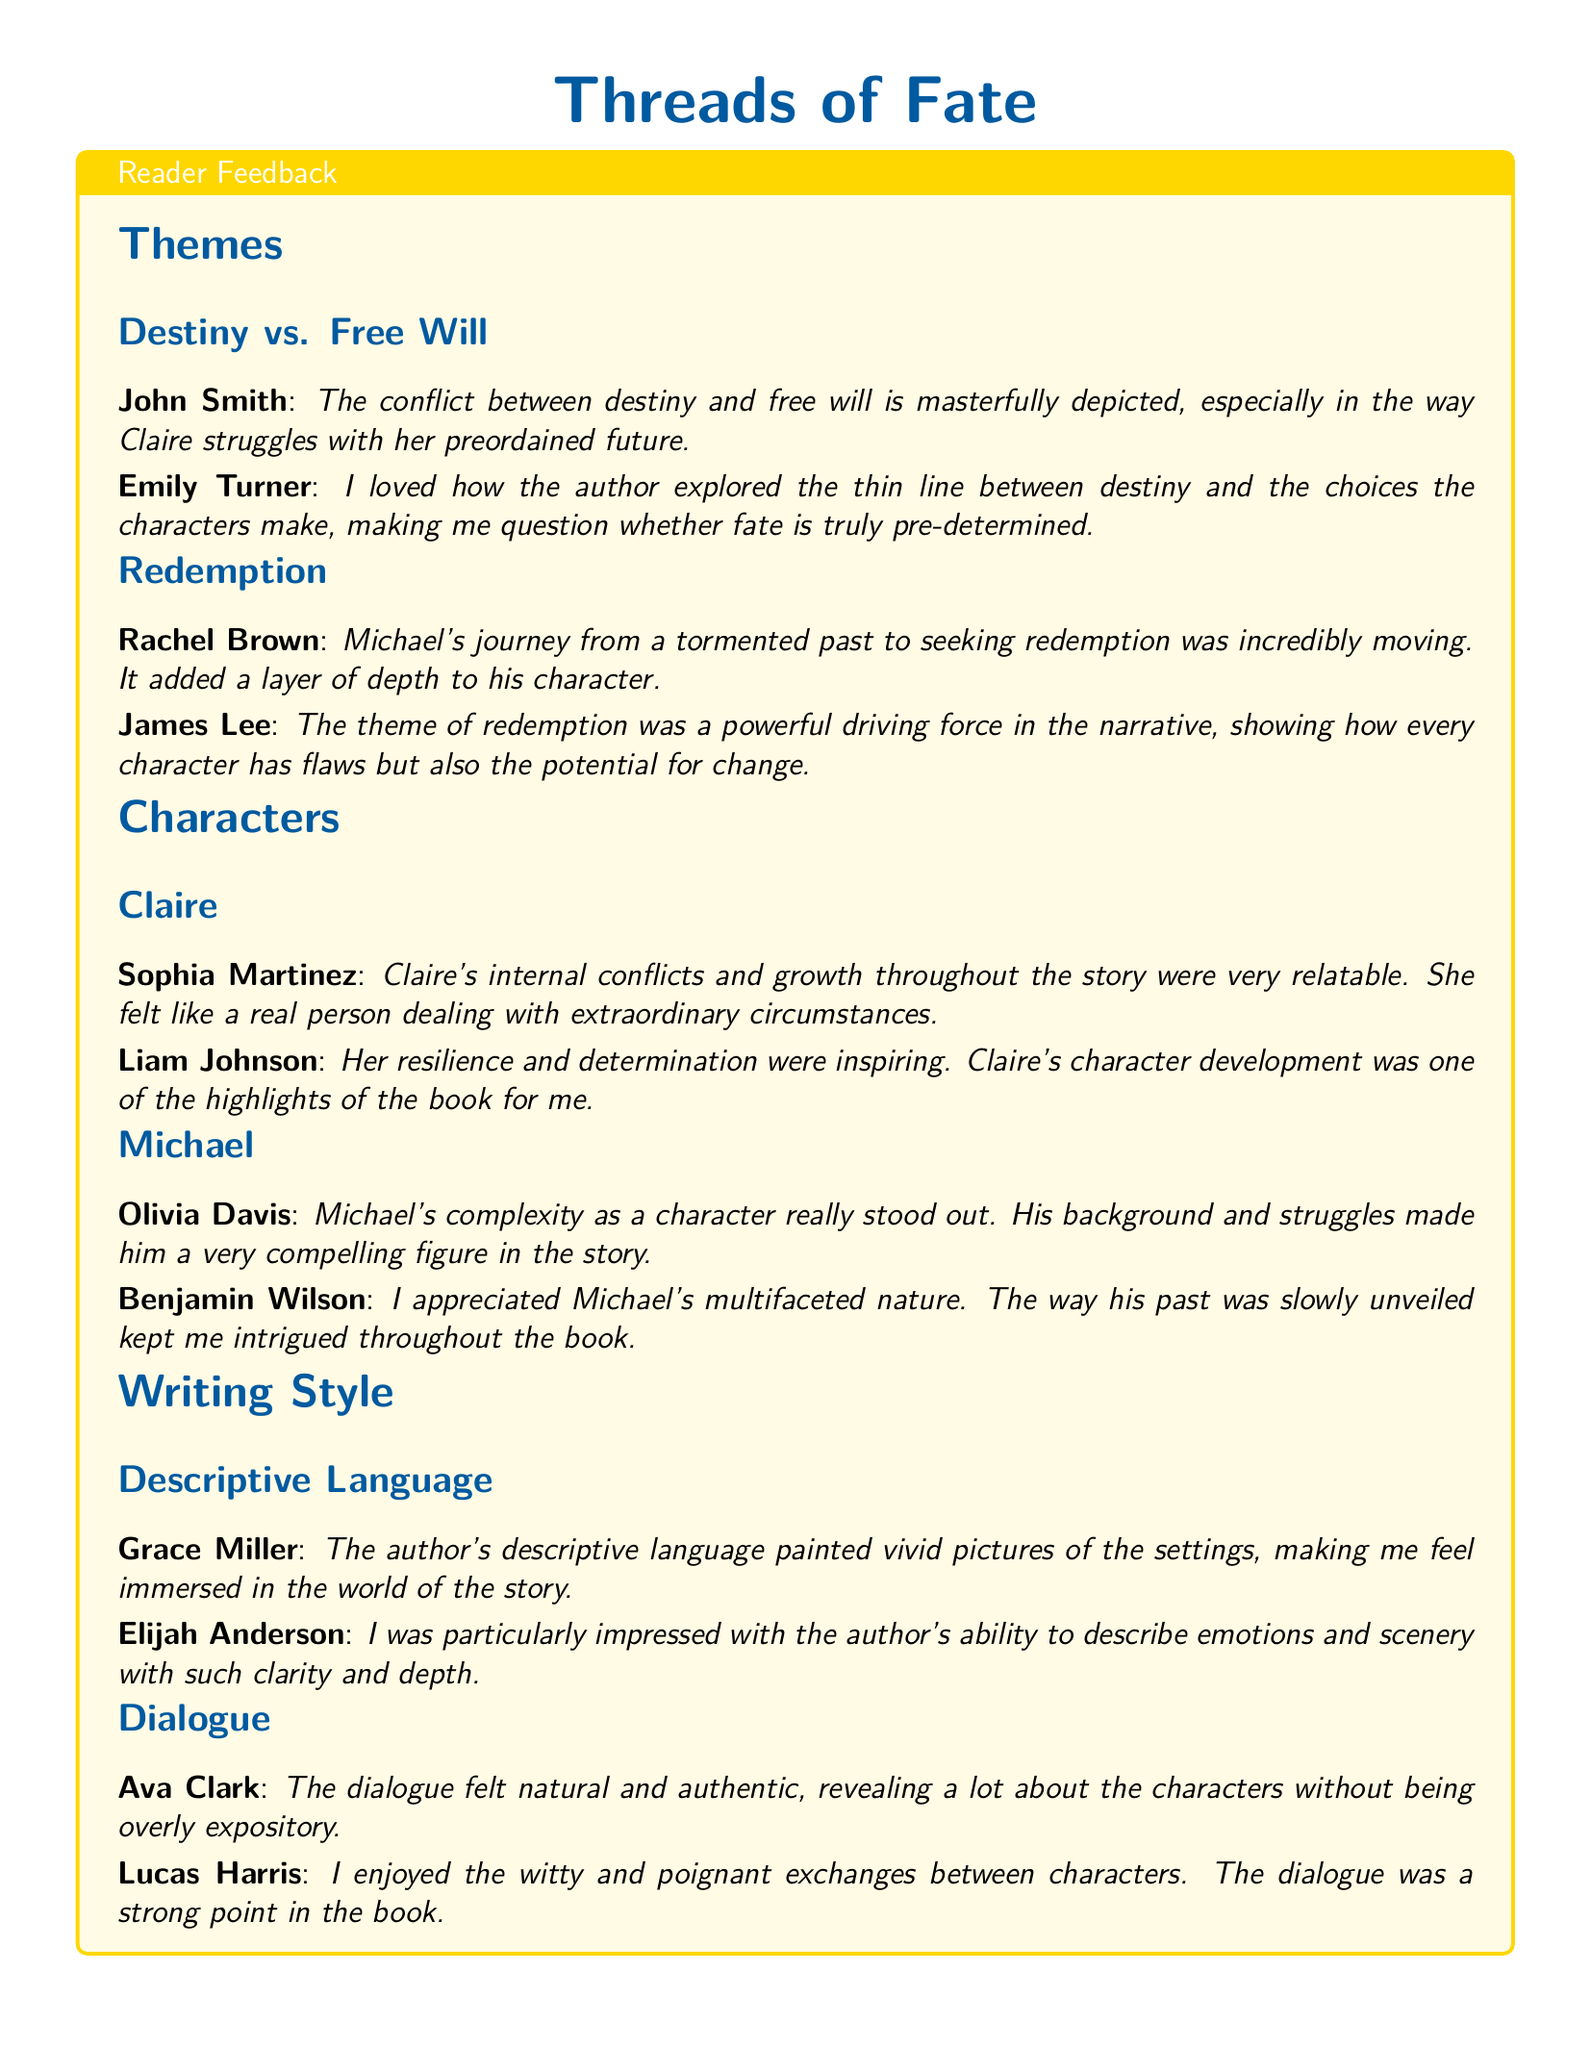What is the title of the book? The title is mentioned at the beginning of the document, prominently displayed.
Answer: Threads of Fate Who described Claire's growth as relatable? This information can be found in the feedback section about Claire's character.
Answer: Sophia Martinez What theme is associated with Michael's character? The theme related to Michael is discussed under his character section.
Answer: Redemption How many readers provided feedback on the writing style? By counting the feedback entries under writing style, we can determine the total.
Answer: Four Which feedback highlighted the expressive dialogue? This feedback specifically points out the quality of dialogue in the narrative.
Answer: Ava Clark What aspect of descriptive language impressed Grace Miller? Grace Miller's feedback focuses on her experience of the settings depicted in the book.
Answer: Immersed in the world Who commented on Michael's complexity? This question seeks the name of the reader who found Michael's complexity notable.
Answer: Olivia Davis What was a powerful driving force in the narrative, according to James Lee? James Lee's feedback identifies this particular theme as significant in the story.
Answer: Redemption What did Elijah Anderson appreciate in the author's writing style? This feedback highlights a specific quality of the author's descriptive abilities.
Answer: Clarity and depth 